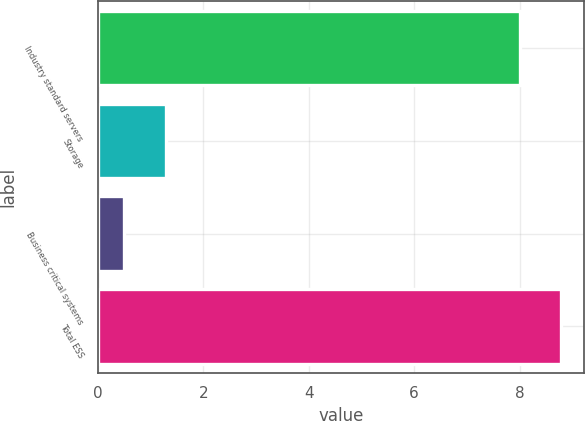<chart> <loc_0><loc_0><loc_500><loc_500><bar_chart><fcel>Industry standard servers<fcel>Storage<fcel>Business critical systems<fcel>Total ESS<nl><fcel>8<fcel>1.29<fcel>0.5<fcel>8.79<nl></chart> 